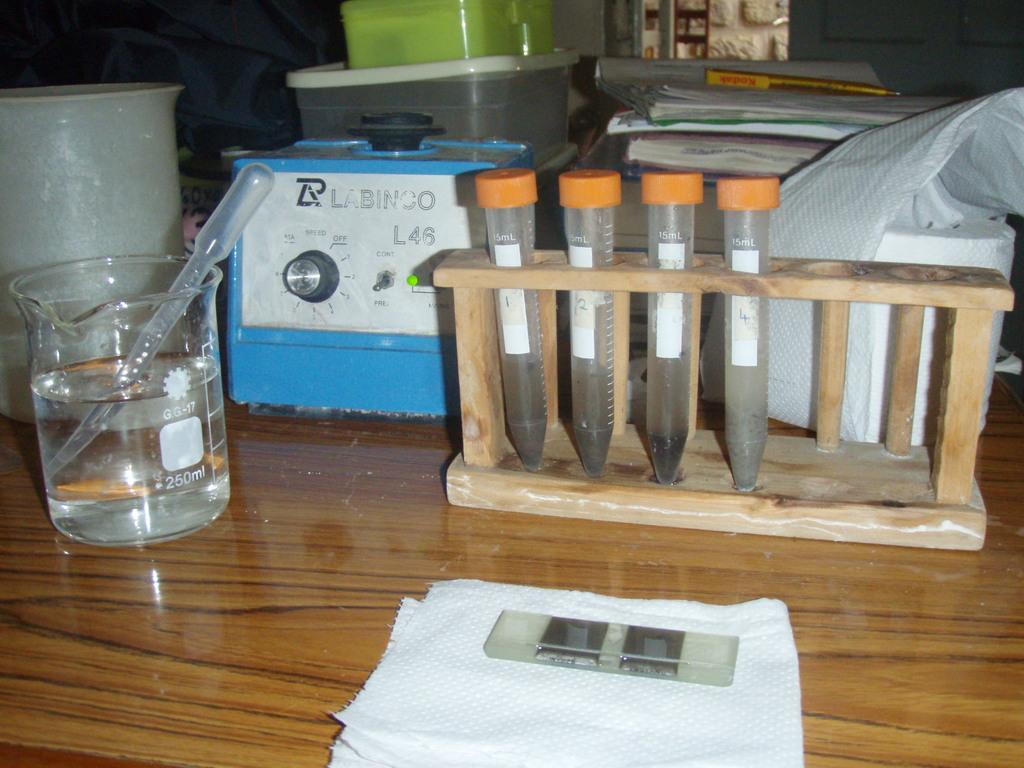Provide a one-sentence caption for the provided image. A blue Labinco piece of equipment is in the middle of a beaker and test tubes on a table. 